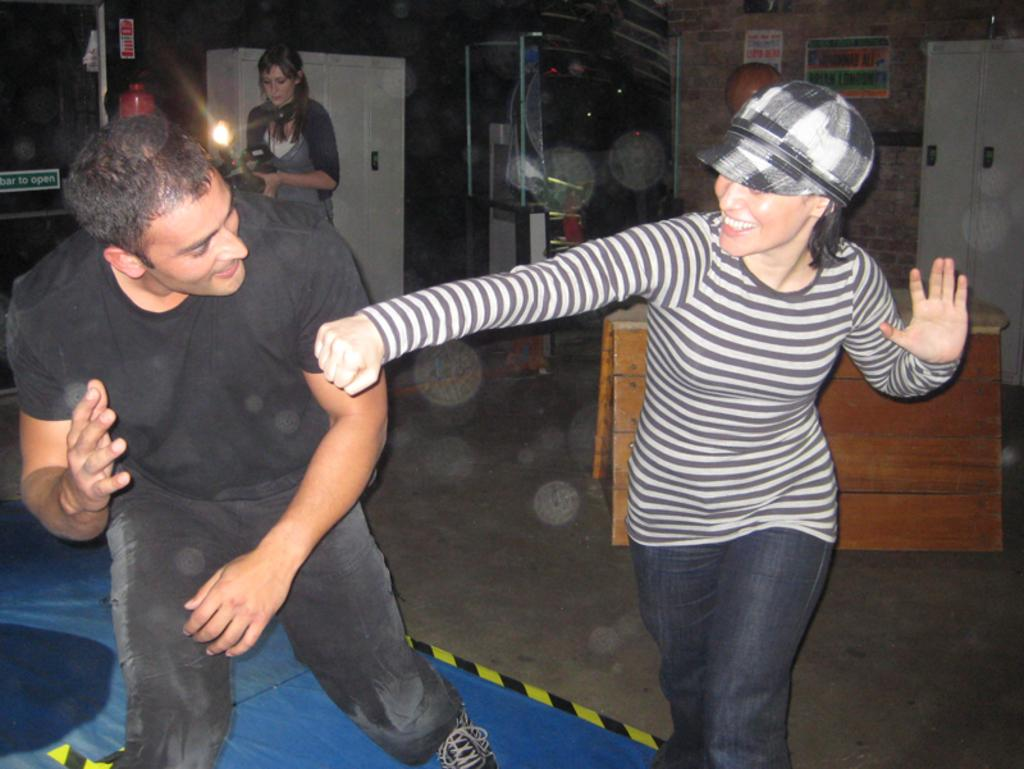How many people are present in the image? There is a boy and a girl in the image. What can be seen in the background of the image? There are posters, cupboards, and racks in the background of the image. What type of animal is visible in the image? There are no animals present in the image. What meal is being prepared in the image? There is no meal preparation visible in the image. 